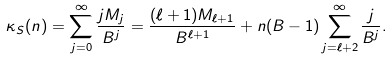<formula> <loc_0><loc_0><loc_500><loc_500>\kappa _ { S } ( n ) = \sum _ { j = 0 } ^ { \infty } \frac { j M _ { j } } { B ^ { j } } = \frac { ( \ell + 1 ) M _ { \ell + 1 } } { B ^ { \ell + 1 } } + n ( B - 1 ) \sum _ { j = \ell + 2 } ^ { \infty } \frac { j } { B ^ { j } } .</formula> 